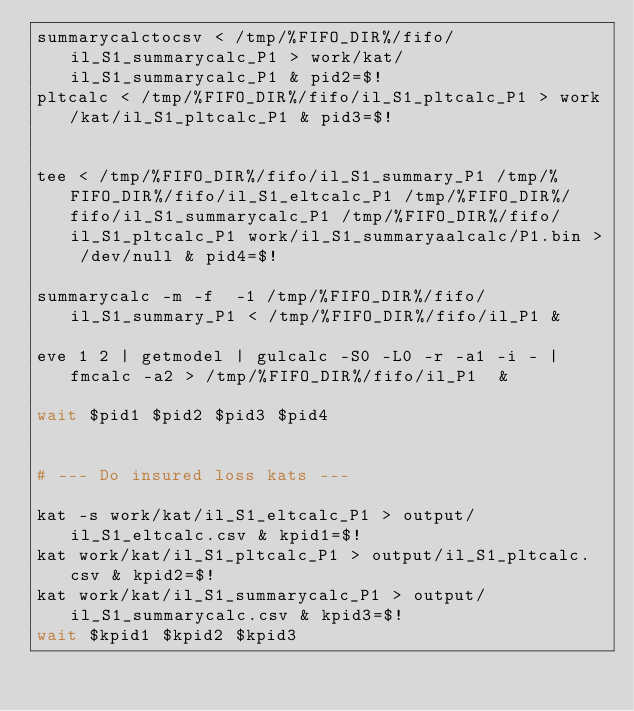<code> <loc_0><loc_0><loc_500><loc_500><_Bash_>summarycalctocsv < /tmp/%FIFO_DIR%/fifo/il_S1_summarycalc_P1 > work/kat/il_S1_summarycalc_P1 & pid2=$!
pltcalc < /tmp/%FIFO_DIR%/fifo/il_S1_pltcalc_P1 > work/kat/il_S1_pltcalc_P1 & pid3=$!


tee < /tmp/%FIFO_DIR%/fifo/il_S1_summary_P1 /tmp/%FIFO_DIR%/fifo/il_S1_eltcalc_P1 /tmp/%FIFO_DIR%/fifo/il_S1_summarycalc_P1 /tmp/%FIFO_DIR%/fifo/il_S1_pltcalc_P1 work/il_S1_summaryaalcalc/P1.bin > /dev/null & pid4=$!

summarycalc -m -f  -1 /tmp/%FIFO_DIR%/fifo/il_S1_summary_P1 < /tmp/%FIFO_DIR%/fifo/il_P1 &

eve 1 2 | getmodel | gulcalc -S0 -L0 -r -a1 -i - | fmcalc -a2 > /tmp/%FIFO_DIR%/fifo/il_P1  &

wait $pid1 $pid2 $pid3 $pid4


# --- Do insured loss kats ---

kat -s work/kat/il_S1_eltcalc_P1 > output/il_S1_eltcalc.csv & kpid1=$!
kat work/kat/il_S1_pltcalc_P1 > output/il_S1_pltcalc.csv & kpid2=$!
kat work/kat/il_S1_summarycalc_P1 > output/il_S1_summarycalc.csv & kpid3=$!
wait $kpid1 $kpid2 $kpid3

</code> 